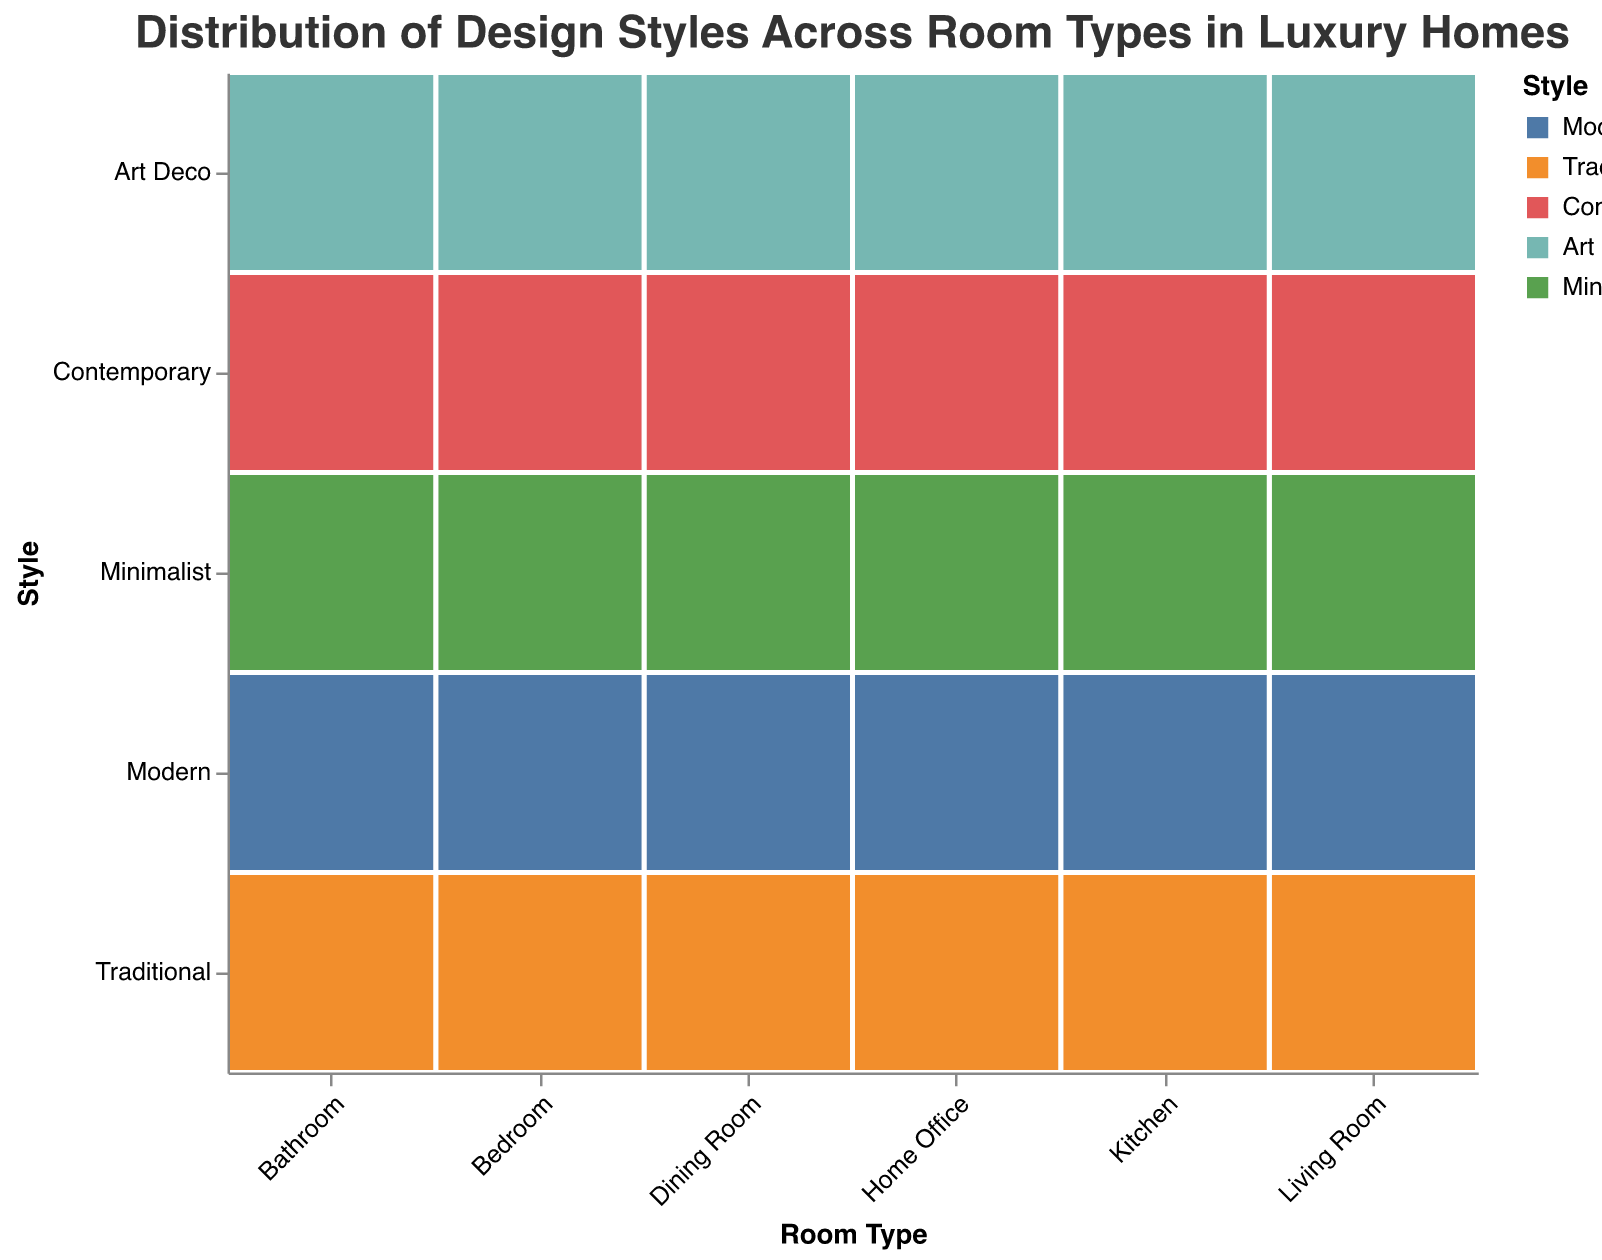What design style is most common in Living Rooms? Look at the section corresponding to "Living Room." The largest rectangle in this section is "Modern."
Answer: Modern Which room type has the highest proportion of Art Deco style? Compare the height of the "Art Deco" rectangles across all room types. The highest "Art Deco" rectangle is in the Bathroom section.
Answer: Bathroom How does the popularity of Minimalist style in Kitchen compare to that in the Dining Room? Compare the size of the "Minimalist" rectangles in the Kitchen and Dining Room sections. The Kitchen has a larger "Minimalist" rectangle than the Dining Room.
Answer: Kitchen Which room has the least amount of Traditional style? Find the smallest "Traditional" rectangles across all the room types. The smallest "Traditional" rectangle is in Bathroom and Home Office, both have the same size.
Answer: Bathroom and Home Office If you combine the value of Modern style in the Living Room and Kitchen, what is the total? Add the values of "Modern" style in the Living Room (30) and Kitchen (35). The total is 30 + 35 = 65.
Answer: 65 Which style is more common in Home Office: Modern or Contemporary? Compare the sizes of the "Modern" and "Contemporary" rectangles in the Home Office section. The "Modern" rectangle is larger than the "Contemporary" one.
Answer: Modern What is the total value of Contemporary style across all room types? Sum the values of "Contemporary" style in all room types: 25 (Living Room) + 30 (Bedroom) + 30 (Kitchen) + 35 (Bathroom) + 20 (Home Office) + 25 (Dining Room). The total is 25 + 30 + 30 + 35 + 20 + 25 = 165.
Answer: 165 Is the proportion of Traditional style in the Dining Room higher than in the Kitchen? Compare the size of the "Traditional" rectangles in the Dining Room and Kitchen sections. The Dining Room has a larger "Traditional" rectangle than the Kitchen.
Answer: Yes How many room types have a higher value of Modern style than Minimalist style? Compare the sizes of "Modern" and "Minimalist" rectangles for each room type. There are five room types: Living Room, Bedroom, Kitchen, Bathroom, and Home Office, where "Modern" is higher than "Minimalist."
Answer: 5 